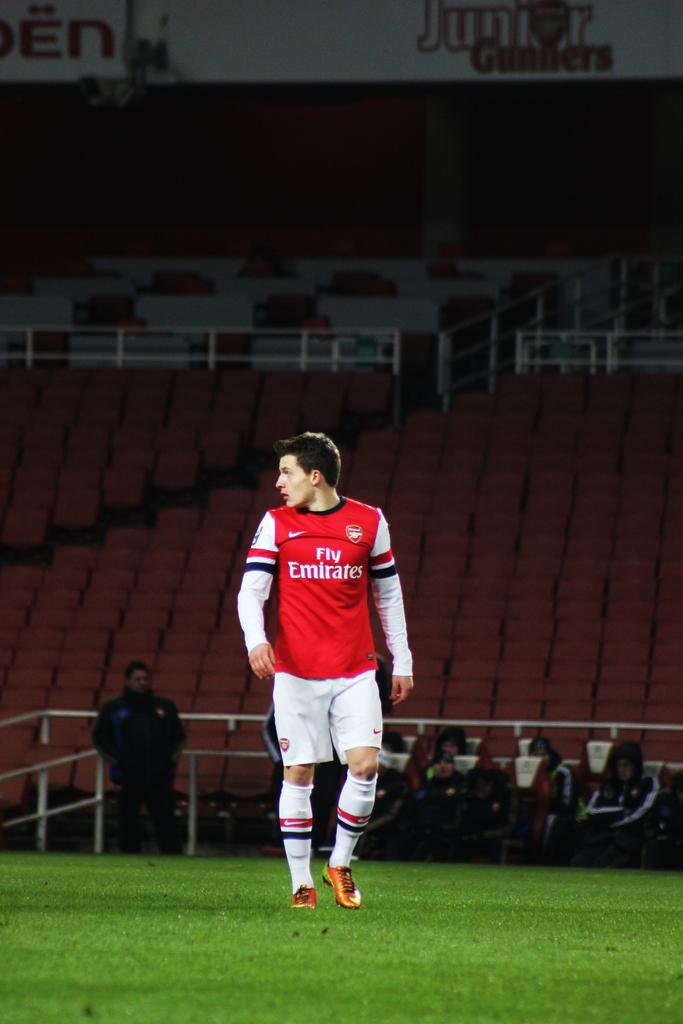<image>
Relay a brief, clear account of the picture shown. Man wearing a red and white jersey that says Fly Emirates. 